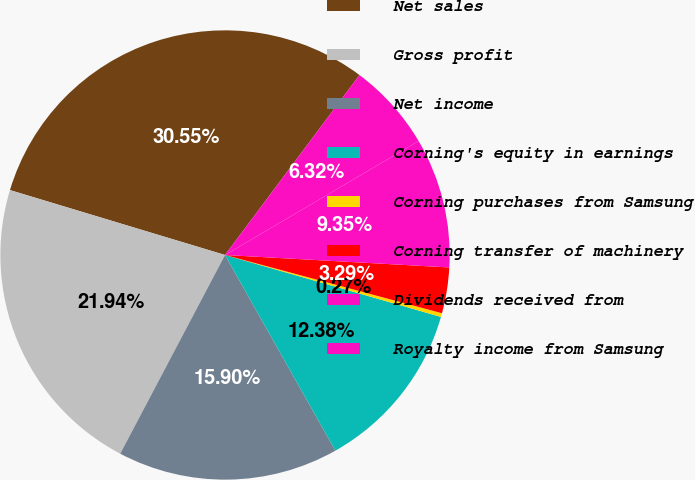Convert chart. <chart><loc_0><loc_0><loc_500><loc_500><pie_chart><fcel>Net sales<fcel>Gross profit<fcel>Net income<fcel>Corning's equity in earnings<fcel>Corning purchases from Samsung<fcel>Corning transfer of machinery<fcel>Dividends received from<fcel>Royalty income from Samsung<nl><fcel>30.55%<fcel>21.94%<fcel>15.9%<fcel>12.38%<fcel>0.27%<fcel>3.29%<fcel>9.35%<fcel>6.32%<nl></chart> 